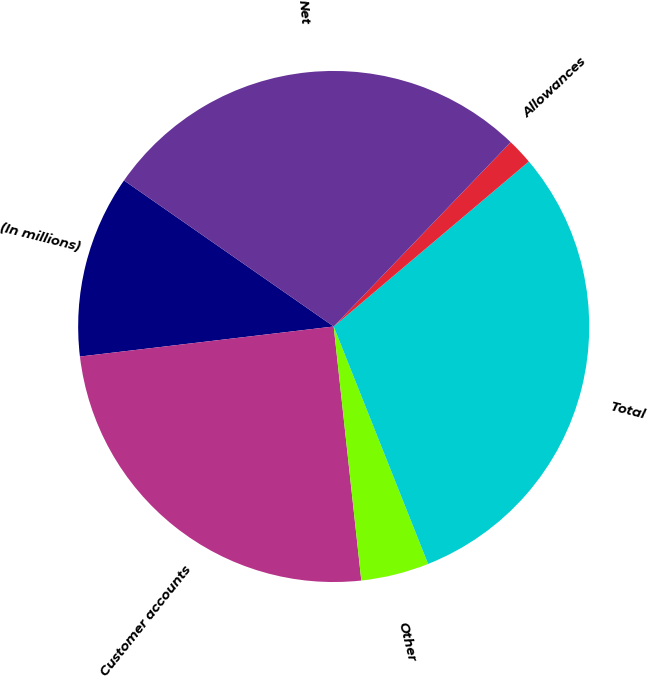Convert chart to OTSL. <chart><loc_0><loc_0><loc_500><loc_500><pie_chart><fcel>(In millions)<fcel>Customer accounts<fcel>Other<fcel>Total<fcel>Allowances<fcel>Net<nl><fcel>11.56%<fcel>24.85%<fcel>4.3%<fcel>30.15%<fcel>1.65%<fcel>27.5%<nl></chart> 